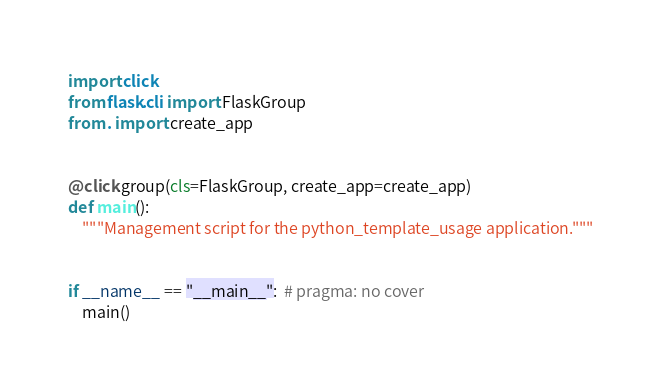Convert code to text. <code><loc_0><loc_0><loc_500><loc_500><_Python_>import click
from flask.cli import FlaskGroup
from . import create_app


@click.group(cls=FlaskGroup, create_app=create_app)
def main():
    """Management script for the python_template_usage application."""


if __name__ == "__main__":  # pragma: no cover
    main()
</code> 